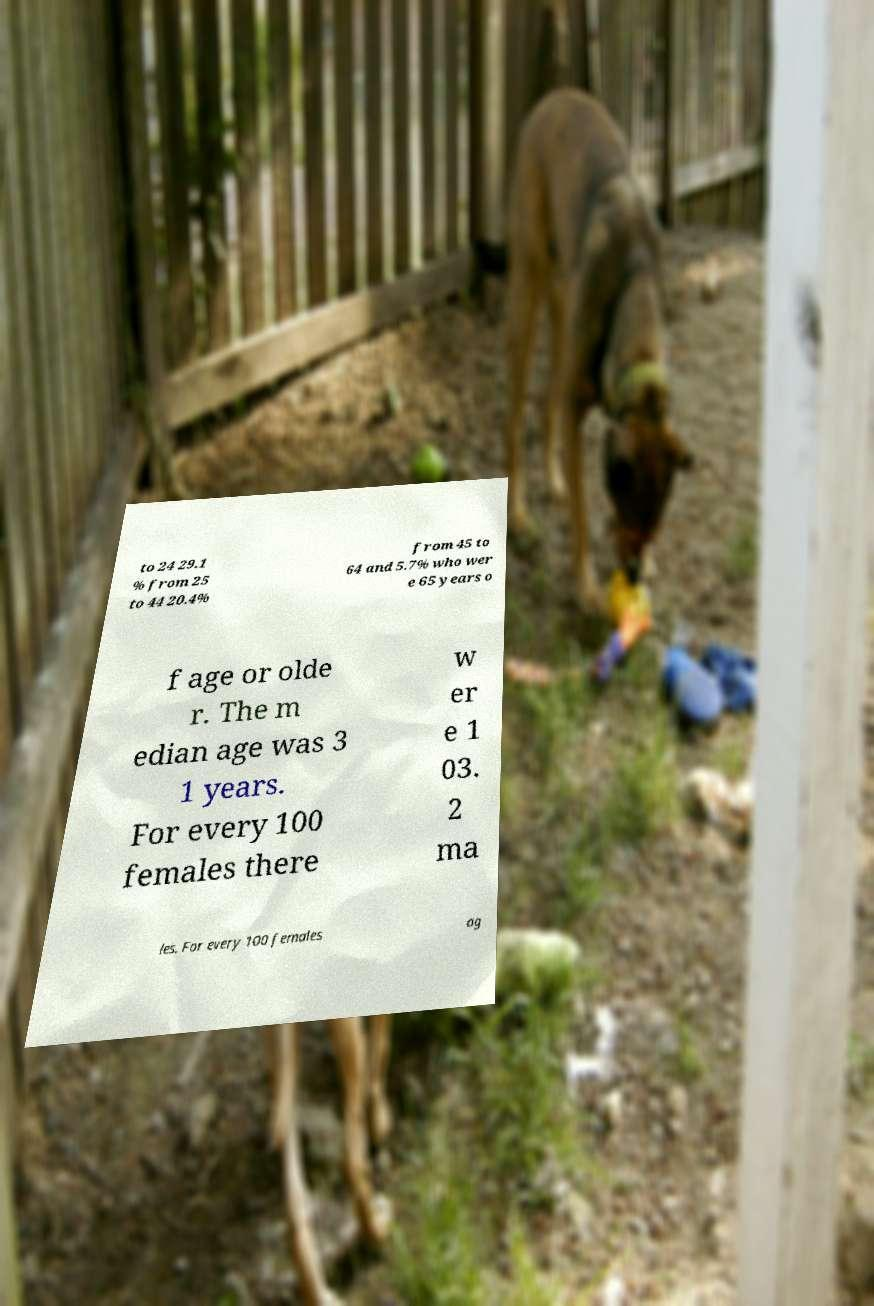Can you read and provide the text displayed in the image?This photo seems to have some interesting text. Can you extract and type it out for me? to 24 29.1 % from 25 to 44 20.4% from 45 to 64 and 5.7% who wer e 65 years o f age or olde r. The m edian age was 3 1 years. For every 100 females there w er e 1 03. 2 ma les. For every 100 females ag 